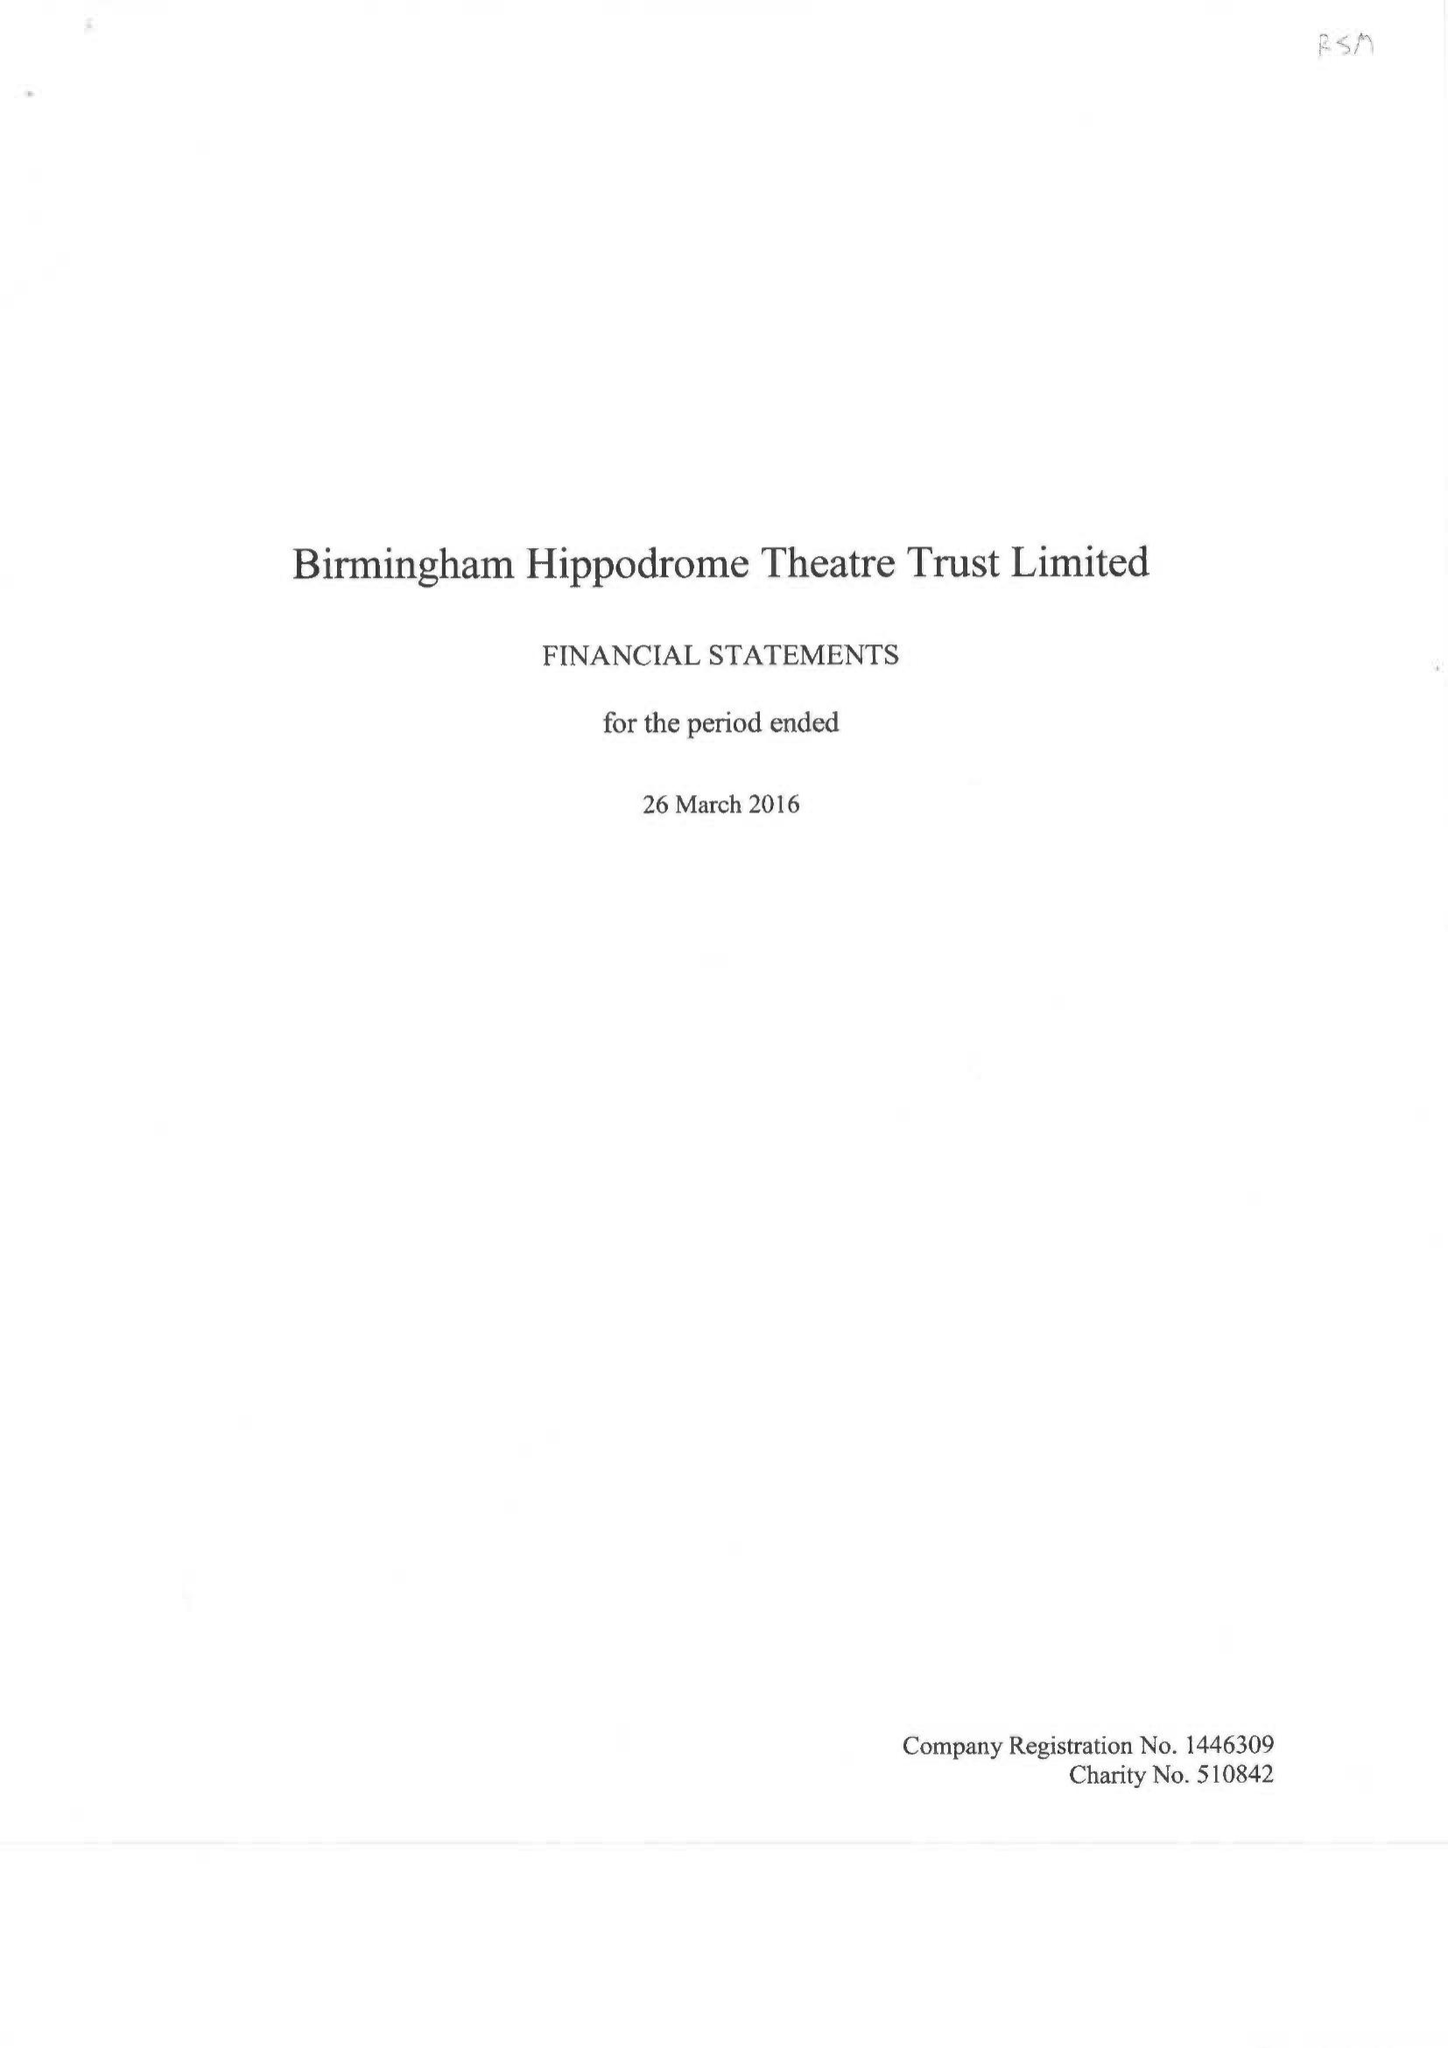What is the value for the report_date?
Answer the question using a single word or phrase. 2016-03-26 